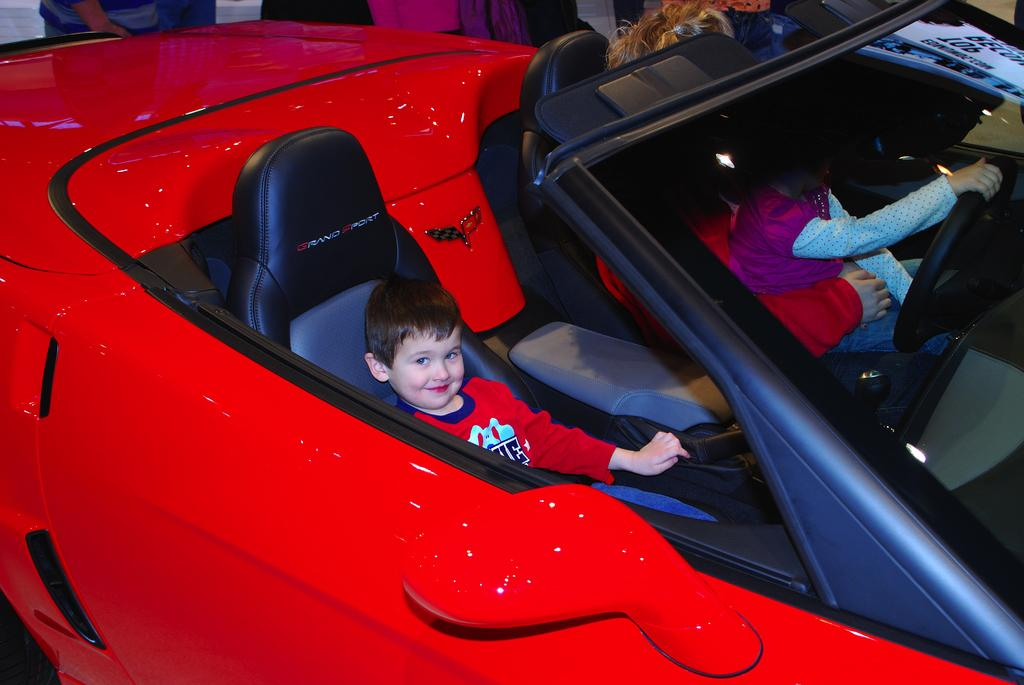What is the main subject in the center of the image? There is a car in the center of the image. Who is inside the car? There is a person in the car, along with two children. What can be seen in the background of the image? There are some persons and objects in the background of the image. What type of balls are being used for teaching in the image? There are no balls or teaching activities present in the image. Is there a shop visible in the background of the image? There is no shop visible in the background of the image. 